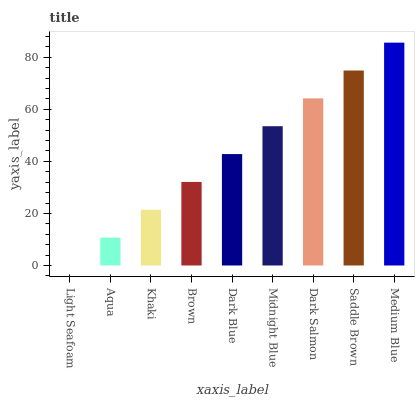Is Light Seafoam the minimum?
Answer yes or no. Yes. Is Medium Blue the maximum?
Answer yes or no. Yes. Is Aqua the minimum?
Answer yes or no. No. Is Aqua the maximum?
Answer yes or no. No. Is Aqua greater than Light Seafoam?
Answer yes or no. Yes. Is Light Seafoam less than Aqua?
Answer yes or no. Yes. Is Light Seafoam greater than Aqua?
Answer yes or no. No. Is Aqua less than Light Seafoam?
Answer yes or no. No. Is Dark Blue the high median?
Answer yes or no. Yes. Is Dark Blue the low median?
Answer yes or no. Yes. Is Light Seafoam the high median?
Answer yes or no. No. Is Brown the low median?
Answer yes or no. No. 